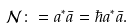Convert formula to latex. <formula><loc_0><loc_0><loc_500><loc_500>\mathcal { N } _ { } \colon = a _ { } ^ { \ast } \bar { a } _ { } = \hbar { a } ^ { \ast } \bar { a } .</formula> 